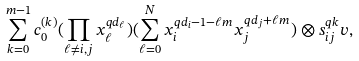Convert formula to latex. <formula><loc_0><loc_0><loc_500><loc_500>\sum _ { k = 0 } ^ { m - 1 } c _ { 0 } ^ { ( k ) } ( \prod _ { \ell \ne i , j } x _ { \ell } ^ { q d _ { \ell } } ) ( \sum _ { \ell = 0 } ^ { N } x _ { i } ^ { q d _ { i } - 1 - \ell m } x _ { j } ^ { q d _ { j } + \ell m } ) \otimes s _ { i j } ^ { q k } v ,</formula> 